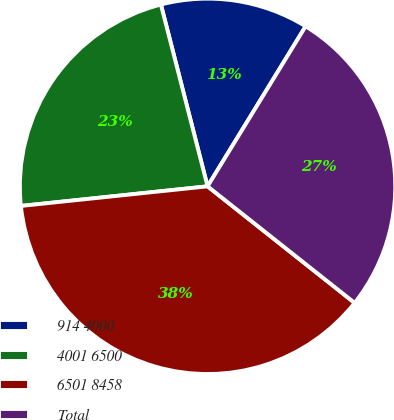Convert chart to OTSL. <chart><loc_0><loc_0><loc_500><loc_500><pie_chart><fcel>9144000<fcel>40016500<fcel>65018458<fcel>Total<nl><fcel>12.75%<fcel>22.67%<fcel>37.67%<fcel>26.92%<nl></chart> 